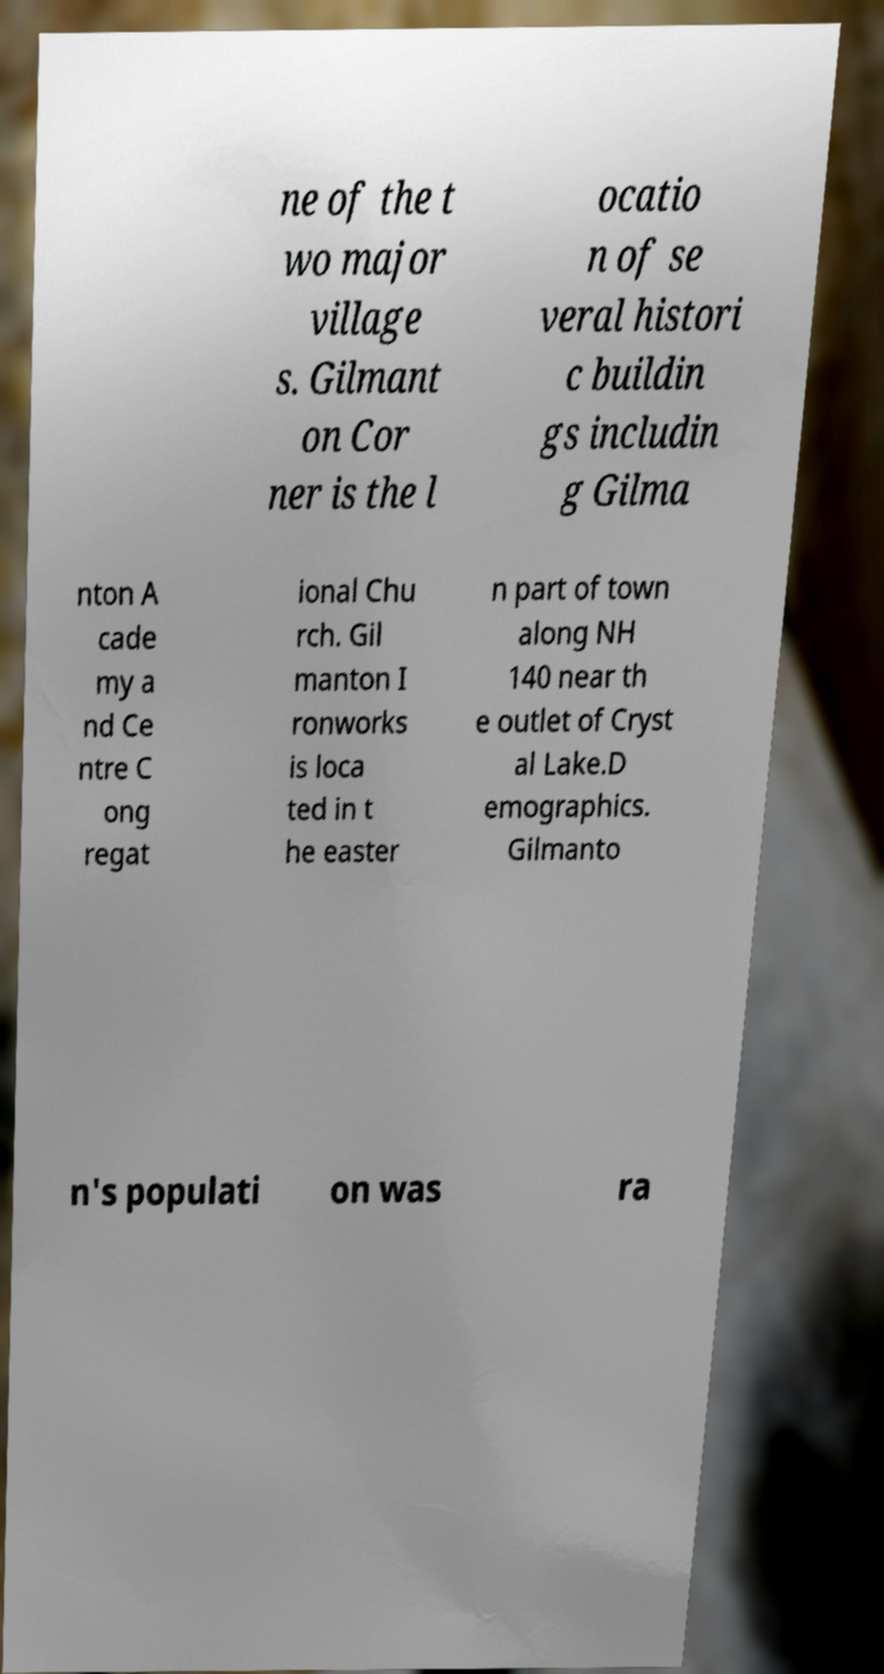Can you read and provide the text displayed in the image?This photo seems to have some interesting text. Can you extract and type it out for me? ne of the t wo major village s. Gilmant on Cor ner is the l ocatio n of se veral histori c buildin gs includin g Gilma nton A cade my a nd Ce ntre C ong regat ional Chu rch. Gil manton I ronworks is loca ted in t he easter n part of town along NH 140 near th e outlet of Cryst al Lake.D emographics. Gilmanto n's populati on was ra 